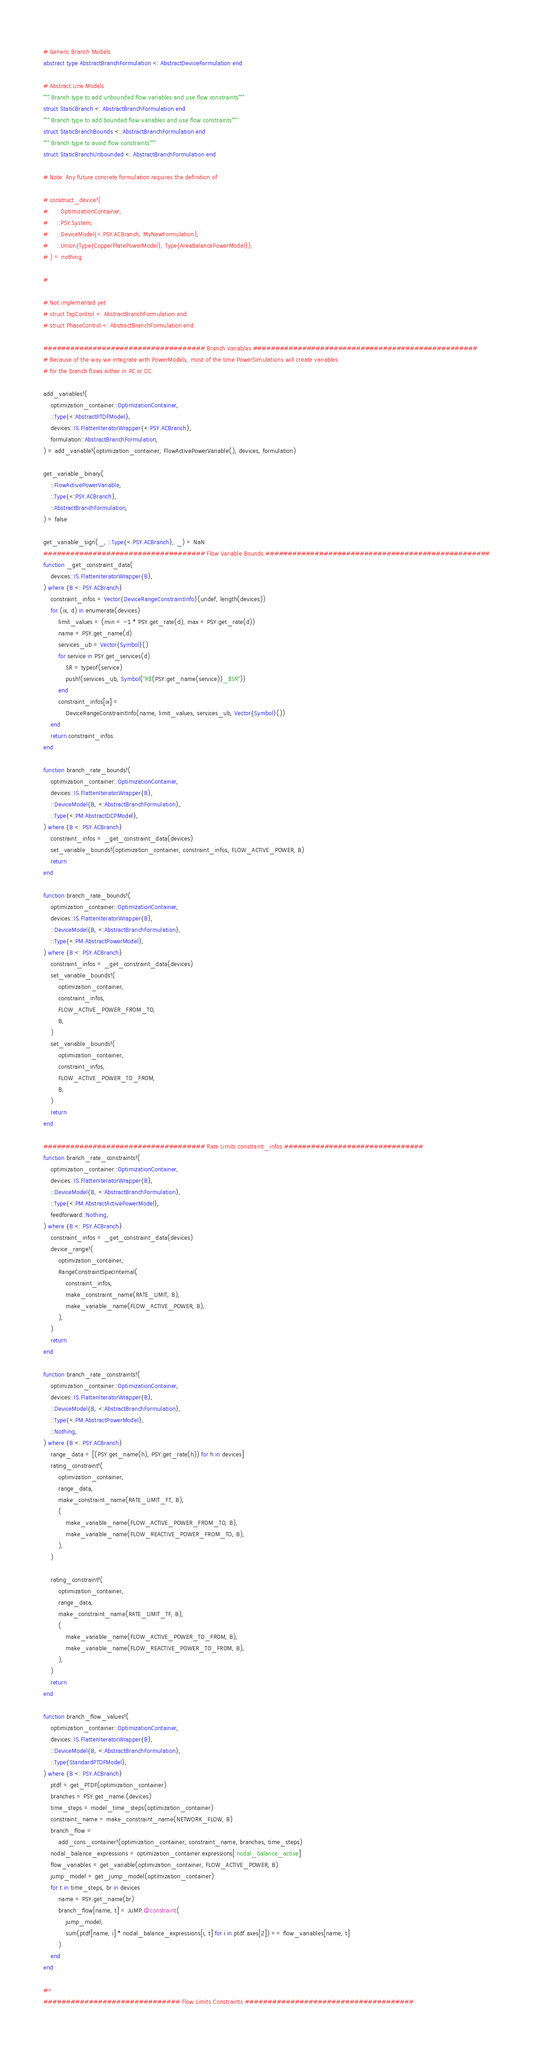Convert code to text. <code><loc_0><loc_0><loc_500><loc_500><_Julia_># Generic Branch Models
abstract type AbstractBranchFormulation <: AbstractDeviceFormulation end

# Abstract Line Models
""" Branch type to add unbounded flow variables and use flow constraints"""
struct StaticBranch <: AbstractBranchFormulation end
""" Branch type to add bounded flow variables and use flow constraints"""
struct StaticBranchBounds <: AbstractBranchFormulation end
""" Branch type to avoid flow constraints"""
struct StaticBranchUnbounded <: AbstractBranchFormulation end

# Note: Any future concrete formulation requires the definition of

# construct_device!(
#     ::OptimizationContainer,
#     ::PSY.System,
#     ::DeviceModel{<:PSY.ACBranch, MyNewFormulation},
#     ::Union{Type{CopperPlatePowerModel}, Type{AreaBalancePowerModel}},
# ) = nothing

#

# Not implemented yet
# struct TapControl <: AbstractBranchFormulation end
# struct PhaseControl <: AbstractBranchFormulation end

#################################### Branch Variables ##################################################
# Because of the way we integrate with PowerModels, most of the time PowerSimulations will create variables
# for the branch flows either in AC or DC.

add_variables!(
    optimization_container::OptimizationContainer,
    ::Type{<:AbstractPTDFModel},
    devices::IS.FlattenIteratorWrapper{<:PSY.ACBranch},
    formulation::AbstractBranchFormulation,
) = add_variable!(optimization_container, FlowActivePowerVariable(), devices, formulation)

get_variable_binary(
    ::FlowActivePowerVariable,
    ::Type{<:PSY.ACBranch},
    ::AbstractBranchFormulation,
) = false

get_variable_sign(_, ::Type{<:PSY.ACBranch}, _) = NaN
#################################### Flow Variable Bounds ##################################################
function _get_constraint_data(
    devices::IS.FlattenIteratorWrapper{B},
) where {B <: PSY.ACBranch}
    constraint_infos = Vector{DeviceRangeConstraintInfo}(undef, length(devices))
    for (ix, d) in enumerate(devices)
        limit_values = (min = -1 * PSY.get_rate(d), max = PSY.get_rate(d))
        name = PSY.get_name(d)
        services_ub = Vector{Symbol}()
        for service in PSY.get_services(d)
            SR = typeof(service)
            push!(services_ub, Symbol("R$(PSY.get_name(service))_$SR"))
        end
        constraint_infos[ix] =
            DeviceRangeConstraintInfo(name, limit_values, services_ub, Vector{Symbol}())
    end
    return constraint_infos
end

function branch_rate_bounds!(
    optimization_container::OptimizationContainer,
    devices::IS.FlattenIteratorWrapper{B},
    ::DeviceModel{B, <:AbstractBranchFormulation},
    ::Type{<:PM.AbstractDCPModel},
) where {B <: PSY.ACBranch}
    constraint_infos = _get_constraint_data(devices)
    set_variable_bounds!(optimization_container, constraint_infos, FLOW_ACTIVE_POWER, B)
    return
end

function branch_rate_bounds!(
    optimization_container::OptimizationContainer,
    devices::IS.FlattenIteratorWrapper{B},
    ::DeviceModel{B, <:AbstractBranchFormulation},
    ::Type{<:PM.AbstractPowerModel},
) where {B <: PSY.ACBranch}
    constraint_infos = _get_constraint_data(devices)
    set_variable_bounds!(
        optimization_container,
        constraint_infos,
        FLOW_ACTIVE_POWER_FROM_TO,
        B,
    )
    set_variable_bounds!(
        optimization_container,
        constraint_infos,
        FLOW_ACTIVE_POWER_TO_FROM,
        B,
    )
    return
end

#################################### Rate Limits constraint_infos ###############################
function branch_rate_constraints!(
    optimization_container::OptimizationContainer,
    devices::IS.FlattenIteratorWrapper{B},
    ::DeviceModel{B, <:AbstractBranchFormulation},
    ::Type{<:PM.AbstractActivePowerModel},
    feedforward::Nothing,
) where {B <: PSY.ACBranch}
    constraint_infos = _get_constraint_data(devices)
    device_range!(
        optimization_container,
        RangeConstraintSpecInternal(
            constraint_infos,
            make_constraint_name(RATE_LIMIT, B),
            make_variable_name(FLOW_ACTIVE_POWER, B),
        ),
    )
    return
end

function branch_rate_constraints!(
    optimization_container::OptimizationContainer,
    devices::IS.FlattenIteratorWrapper{B},
    ::DeviceModel{B, <:AbstractBranchFormulation},
    ::Type{<:PM.AbstractPowerModel},
    ::Nothing,
) where {B <: PSY.ACBranch}
    range_data = [(PSY.get_name(h), PSY.get_rate(h)) for h in devices]
    rating_constraint!(
        optimization_container,
        range_data,
        make_constraint_name(RATE_LIMIT_FT, B),
        (
            make_variable_name(FLOW_ACTIVE_POWER_FROM_TO, B),
            make_variable_name(FLOW_REACTIVE_POWER_FROM_TO, B),
        ),
    )

    rating_constraint!(
        optimization_container,
        range_data,
        make_constraint_name(RATE_LIMIT_TF, B),
        (
            make_variable_name(FLOW_ACTIVE_POWER_TO_FROM, B),
            make_variable_name(FLOW_REACTIVE_POWER_TO_FROM, B),
        ),
    )
    return
end

function branch_flow_values!(
    optimization_container::OptimizationContainer,
    devices::IS.FlattenIteratorWrapper{B},
    ::DeviceModel{B, <:AbstractBranchFormulation},
    ::Type{StandardPTDFModel},
) where {B <: PSY.ACBranch}
    ptdf = get_PTDF(optimization_container)
    branches = PSY.get_name.(devices)
    time_steps = model_time_steps(optimization_container)
    constraint_name = make_constraint_name(NETWORK_FLOW, B)
    branch_flow =
        add_cons_container!(optimization_container, constraint_name, branches, time_steps)
    nodal_balance_expressions = optimization_container.expressions[:nodal_balance_active]
    flow_variables = get_variable(optimization_container, FLOW_ACTIVE_POWER, B)
    jump_model = get_jump_model(optimization_container)
    for t in time_steps, br in devices
        name = PSY.get_name(br)
        branch_flow[name, t] = JuMP.@constraint(
            jump_model,
            sum(ptdf[name, i] * nodal_balance_expressions[i, t] for i in ptdf.axes[2]) == flow_variables[name, t]
        )
    end
end

#=
############################## Flow Limits Constraints #####################################</code> 